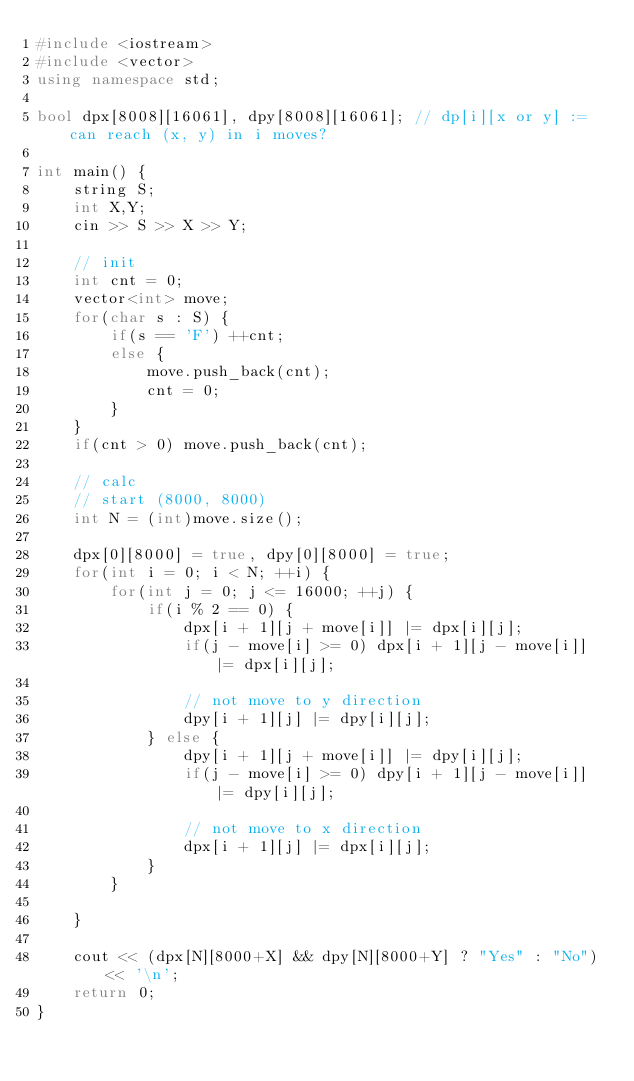<code> <loc_0><loc_0><loc_500><loc_500><_C++_>#include <iostream>
#include <vector>
using namespace std;

bool dpx[8008][16061], dpy[8008][16061]; // dp[i][x or y] := can reach (x, y) in i moves?

int main() {
    string S;
    int X,Y;
    cin >> S >> X >> Y;

    // init
    int cnt = 0;
    vector<int> move;
    for(char s : S) {
        if(s == 'F') ++cnt;
        else {
            move.push_back(cnt);
            cnt = 0;
        }
    }
    if(cnt > 0) move.push_back(cnt);

    // calc
    // start (8000, 8000)
    int N = (int)move.size();

    dpx[0][8000] = true, dpy[0][8000] = true;
    for(int i = 0; i < N; ++i) {
        for(int j = 0; j <= 16000; ++j) {
            if(i % 2 == 0) {
                dpx[i + 1][j + move[i]] |= dpx[i][j];
                if(j - move[i] >= 0) dpx[i + 1][j - move[i]] |= dpx[i][j];

                // not move to y direction
                dpy[i + 1][j] |= dpy[i][j];
            } else {
                dpy[i + 1][j + move[i]] |= dpy[i][j];
                if(j - move[i] >= 0) dpy[i + 1][j - move[i]] |= dpy[i][j];

                // not move to x direction
                dpx[i + 1][j] |= dpx[i][j];
            }
        }

    }

    cout << (dpx[N][8000+X] && dpy[N][8000+Y] ? "Yes" : "No") << '\n';
    return 0;
}</code> 